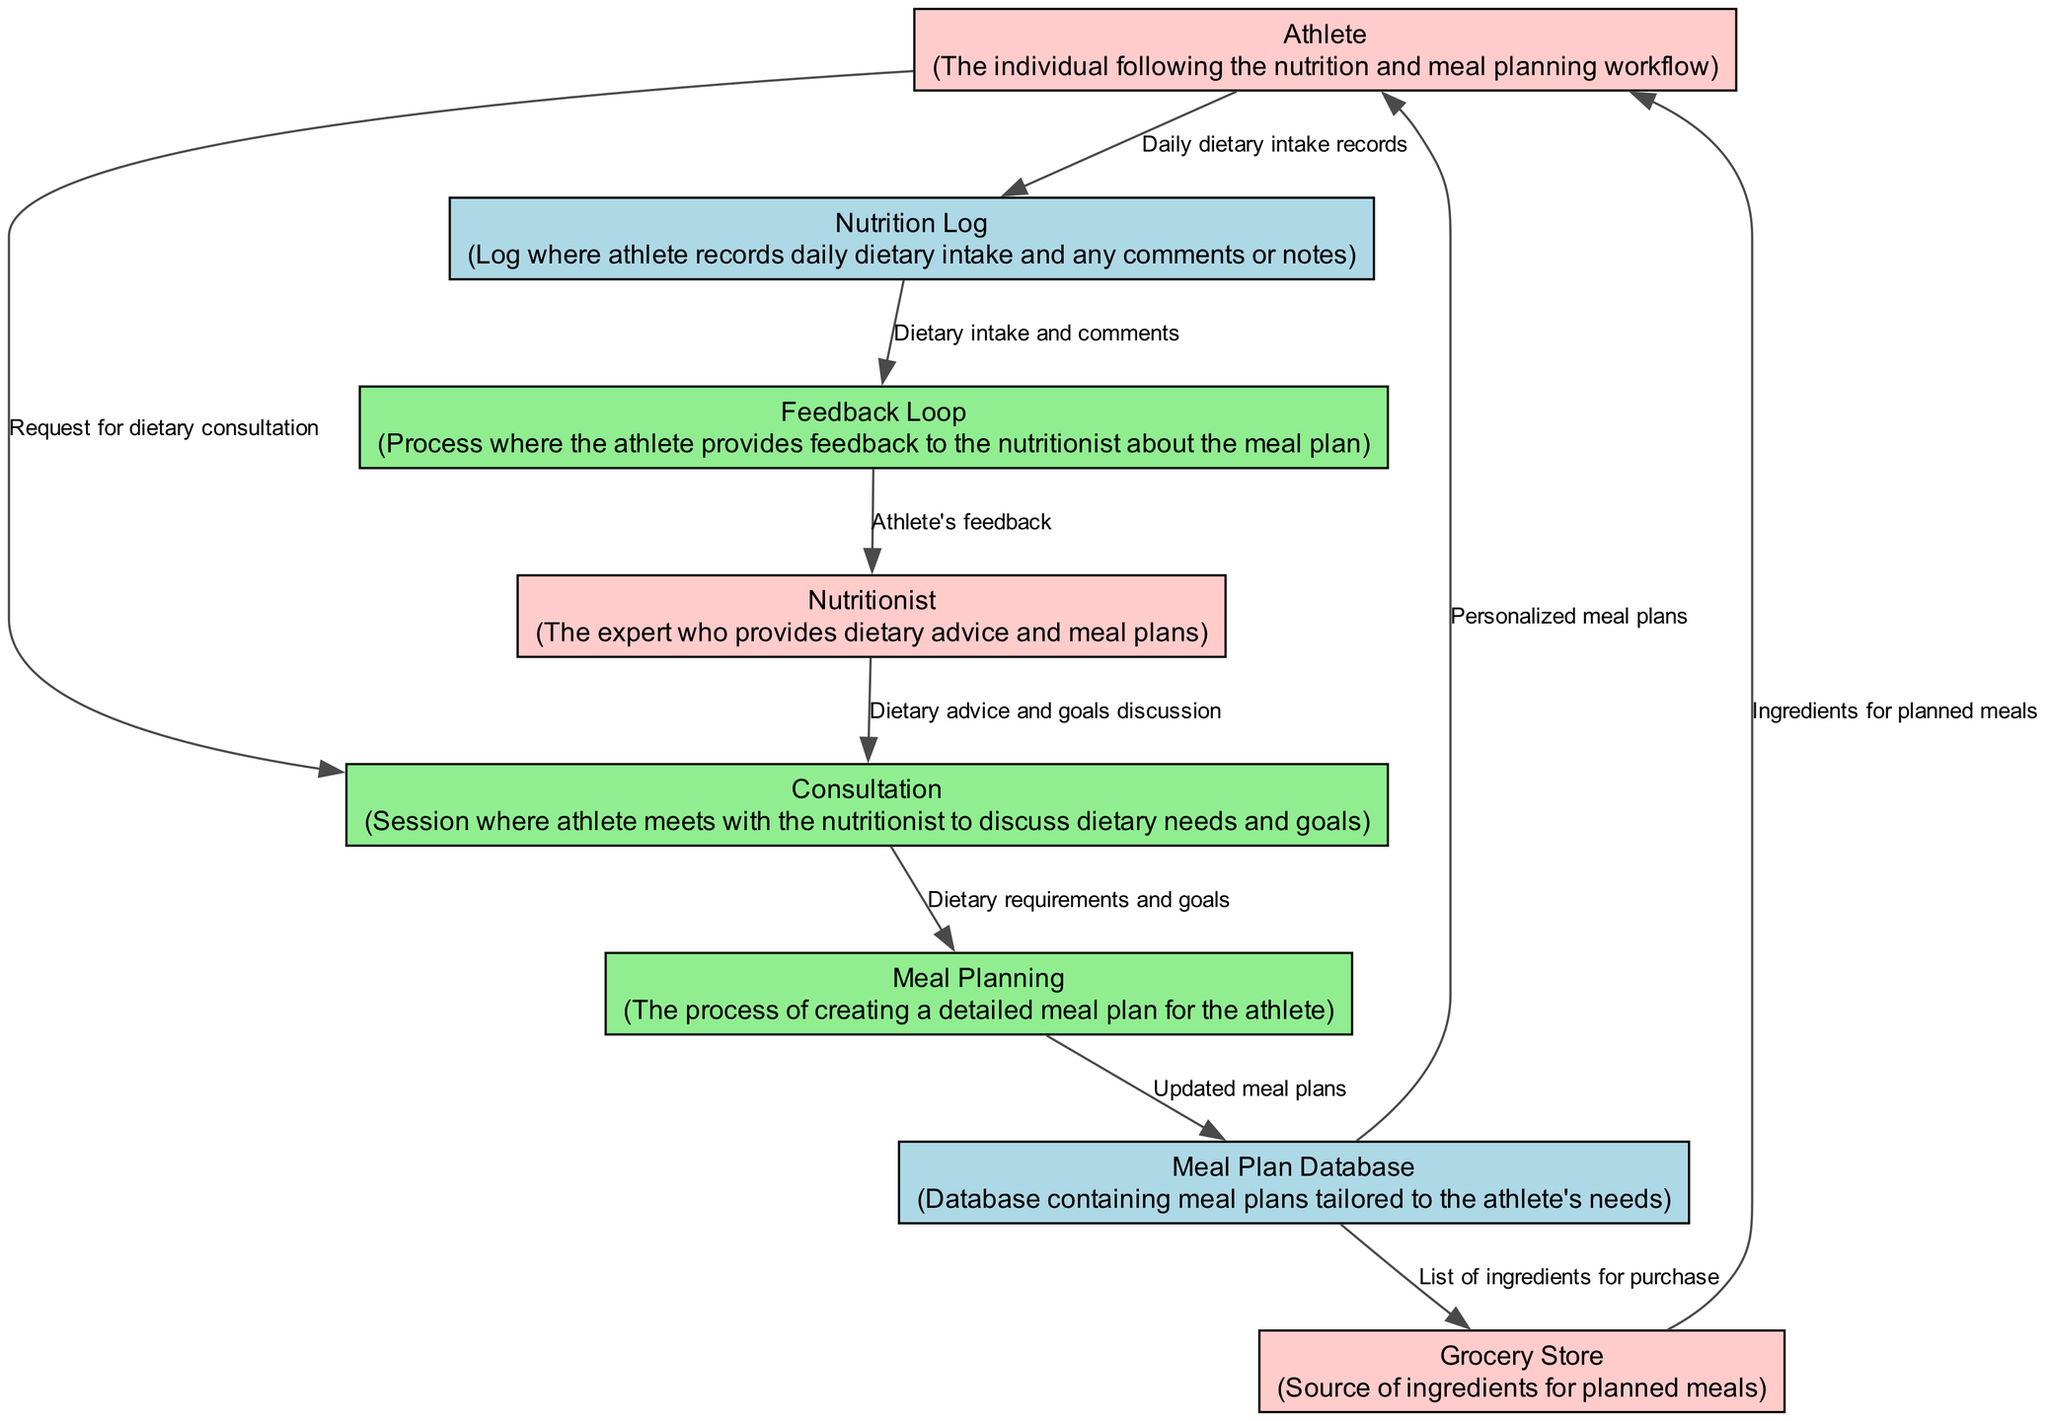What is the first process in the workflow? The first process depicted in the diagram is "Consultation." This can be determined by looking at the nodes and identifying that "Consultation" is the first labeled process before any of the other processes occur.
Answer: Consultation How many external entities are present in the diagram? The diagram includes three external entities: Athlete, Nutritionist, and Grocery Store. By counting the labeled nodes that are classified as "external_entity," we arrive at this total.
Answer: 3 What type of data store is linked to the Meal Planning process? The data store linked to the Meal Planning process is the "Meal Plan Database." This relationship is found by following the data flows from the "Meal Planning" process to the respective data stores and looking for the one it's connected to.
Answer: Meal Plan Database What feedback mechanism exists in this workflow? The workflow features a "Feedback Loop" where the athlete provides feedback to the nutritionist. This is represented as a distinct process and flows from the "Nutrition Log" to the "Nutritionist."
Answer: Feedback Loop Which external entity provides the ingredients for planned meals? The "Grocery Store" is the external entity that provides the ingredients for planned meals. This is identified by examining the data flow directly connecting "Grocery Store" to the "Athlete."
Answer: Grocery Store In the workflow, what is the final destination of the personalized meal plans? The final destination of the personalized meal plans is the "Athlete." By tracing the data flow from "Meal Plan Database" to "Athlete," it is evident that this is where the meal plans are sent after being created.
Answer: Athlete How does the athlete log their daily dietary intake? The athlete logs their daily dietary intake by sending records to the "Nutrition Log." This connection is shown by the direct data flow from "Athlete" to "Nutrition Log."
Answer: Nutrition Log What is included in the Grocery Store data flow from the Meal Plan Database? The Grocery Store data flow from the Meal Plan Database includes a "List of ingredients for purchase." This is indicated by the distinct data flow from "Meal Plan Database" to "Grocery Store" labeled with this description.
Answer: List of ingredients for purchase What process follows after the athlete meets with the nutritionist? After the athlete meets with the nutritionist in the "Consultation" process, the next process is "Meal Planning." This is established by following the data flow from "Consultation" to "Meal Planning."
Answer: Meal Planning 